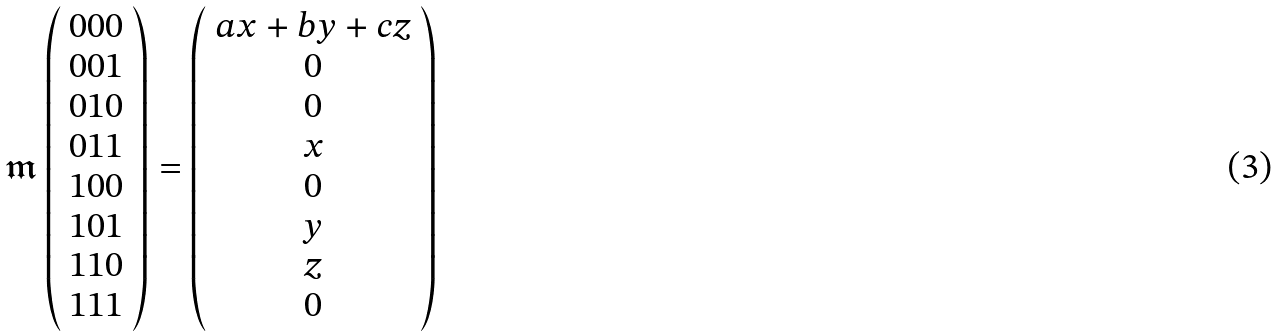<formula> <loc_0><loc_0><loc_500><loc_500>\mathfrak { m } \left ( \begin{array} { c } 0 0 0 \\ 0 0 1 \\ 0 1 0 \\ 0 1 1 \\ 1 0 0 \\ 1 0 1 \\ 1 1 0 \\ 1 1 1 \end{array} \right ) = \left ( \begin{array} { c } a x + b y + c z \\ 0 \\ 0 \\ x \\ 0 \\ y \\ z \\ 0 \end{array} \right )</formula> 